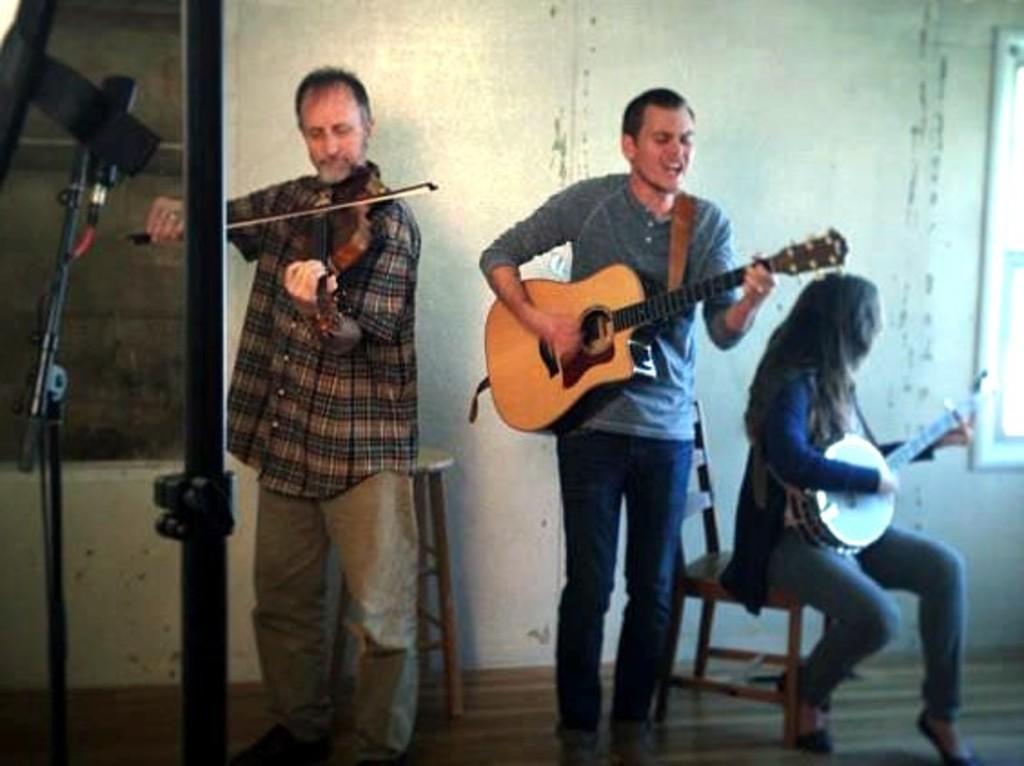Describe this image in one or two sentences. In this picture we can see a wall,and in front a person is standing and playing a violin, and right to opposite a man is standing and playing a guitar, and singing and right to opposite a woman is sitting in chair and playing musical drums ,and here is the stand on the floor. 